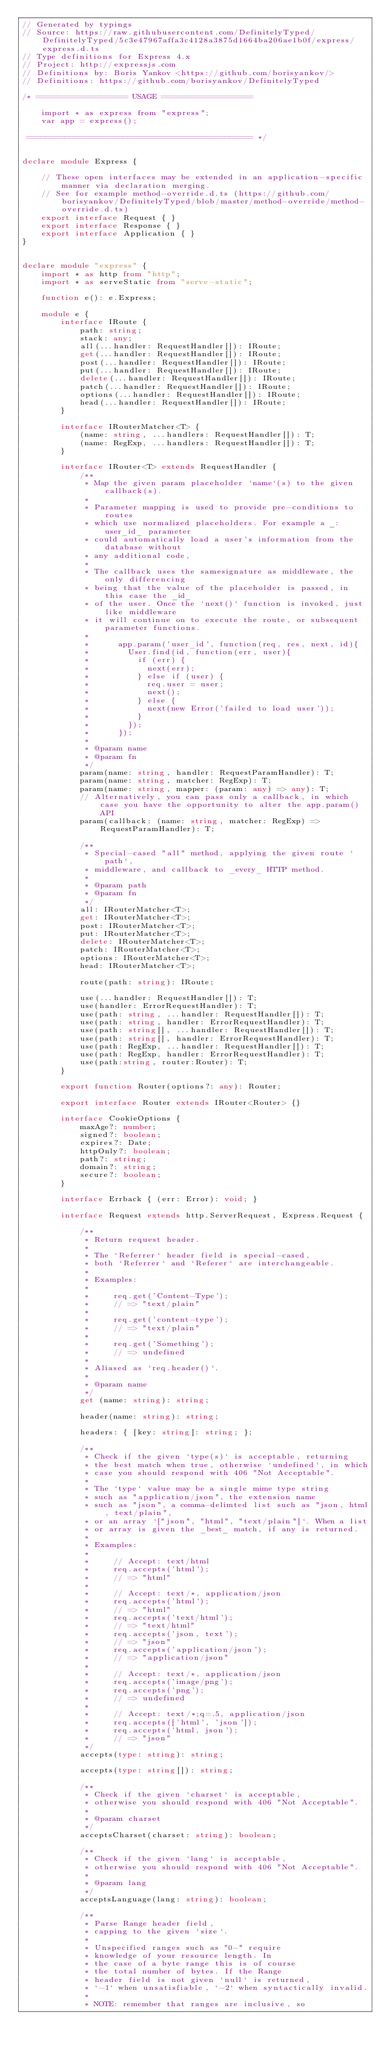Convert code to text. <code><loc_0><loc_0><loc_500><loc_500><_TypeScript_>// Generated by typings
// Source: https://raw.githubusercontent.com/DefinitelyTyped/DefinitelyTyped/5c3e47967affa3c4128a3875d1664ba206ae1b0f/express/express.d.ts
// Type definitions for Express 4.x
// Project: http://expressjs.com
// Definitions by: Boris Yankov <https://github.com/borisyankov/>
// Definitions: https://github.com/borisyankov/DefinitelyTyped

/* =================== USAGE ===================

    import * as express from "express";
    var app = express();

 =============================================== */


declare module Express {

    // These open interfaces may be extended in an application-specific manner via declaration merging.
    // See for example method-override.d.ts (https://github.com/borisyankov/DefinitelyTyped/blob/master/method-override/method-override.d.ts)
    export interface Request { }
    export interface Response { }
    export interface Application { }
}


declare module "express" {
    import * as http from "http";
    import * as serveStatic from "serve-static";

    function e(): e.Express;

    module e {
        interface IRoute {
            path: string;
            stack: any;
            all(...handler: RequestHandler[]): IRoute;
            get(...handler: RequestHandler[]): IRoute;
            post(...handler: RequestHandler[]): IRoute;
            put(...handler: RequestHandler[]): IRoute;
            delete(...handler: RequestHandler[]): IRoute;
            patch(...handler: RequestHandler[]): IRoute;
            options(...handler: RequestHandler[]): IRoute;
            head(...handler: RequestHandler[]): IRoute;
        }

        interface IRouterMatcher<T> {
            (name: string, ...handlers: RequestHandler[]): T;
            (name: RegExp, ...handlers: RequestHandler[]): T;
        }

        interface IRouter<T> extends RequestHandler {
            /**
             * Map the given param placeholder `name`(s) to the given callback(s).
             *
             * Parameter mapping is used to provide pre-conditions to routes
             * which use normalized placeholders. For example a _:user_id_ parameter
             * could automatically load a user's information from the database without
             * any additional code,
             *
             * The callback uses the samesignature as middleware, the only differencing
             * being that the value of the placeholder is passed, in this case the _id_
             * of the user. Once the `next()` function is invoked, just like middleware
             * it will continue on to execute the route, or subsequent parameter functions.
             *
             *      app.param('user_id', function(req, res, next, id){
             *        User.find(id, function(err, user){
             *          if (err) {
             *            next(err);
             *          } else if (user) {
             *            req.user = user;
             *            next();
             *          } else {
             *            next(new Error('failed to load user'));
             *          }
             *        });
             *      });
             *
             * @param name
             * @param fn
             */
            param(name: string, handler: RequestParamHandler): T;
            param(name: string, matcher: RegExp): T;
            param(name: string, mapper: (param: any) => any): T;
            // Alternatively, you can pass only a callback, in which case you have the opportunity to alter the app.param() API
            param(callback: (name: string, matcher: RegExp) => RequestParamHandler): T;

            /**
             * Special-cased "all" method, applying the given route `path`,
             * middleware, and callback to _every_ HTTP method.
             *
             * @param path
             * @param fn
             */
            all: IRouterMatcher<T>;
            get: IRouterMatcher<T>;
            post: IRouterMatcher<T>;
            put: IRouterMatcher<T>;
            delete: IRouterMatcher<T>;
            patch: IRouterMatcher<T>;
            options: IRouterMatcher<T>;
            head: IRouterMatcher<T>;

            route(path: string): IRoute;

            use(...handler: RequestHandler[]): T;
            use(handler: ErrorRequestHandler): T;
            use(path: string, ...handler: RequestHandler[]): T;
            use(path: string, handler: ErrorRequestHandler): T;
            use(path: string[], ...handler: RequestHandler[]): T;
            use(path: string[], handler: ErrorRequestHandler): T;
            use(path: RegExp, ...handler: RequestHandler[]): T;
            use(path: RegExp, handler: ErrorRequestHandler): T;
            use(path:string, router:Router): T;
        }

        export function Router(options?: any): Router;

        export interface Router extends IRouter<Router> {}

        interface CookieOptions {
            maxAge?: number;
            signed?: boolean;
            expires?: Date;
            httpOnly?: boolean;
            path?: string;
            domain?: string;
            secure?: boolean;
        }

        interface Errback { (err: Error): void; }

        interface Request extends http.ServerRequest, Express.Request {

            /**
             * Return request header.
             *
             * The `Referrer` header field is special-cased,
             * both `Referrer` and `Referer` are interchangeable.
             *
             * Examples:
             *
             *     req.get('Content-Type');
             *     // => "text/plain"
             *
             *     req.get('content-type');
             *     // => "text/plain"
             *
             *     req.get('Something');
             *     // => undefined
             *
             * Aliased as `req.header()`.
             *
             * @param name
             */
            get (name: string): string;

            header(name: string): string;

            headers: { [key: string]: string; };

            /**
             * Check if the given `type(s)` is acceptable, returning
             * the best match when true, otherwise `undefined`, in which
             * case you should respond with 406 "Not Acceptable".
             *
             * The `type` value may be a single mime type string
             * such as "application/json", the extension name
             * such as "json", a comma-delimted list such as "json, html, text/plain",
             * or an array `["json", "html", "text/plain"]`. When a list
             * or array is given the _best_ match, if any is returned.
             *
             * Examples:
             *
             *     // Accept: text/html
             *     req.accepts('html');
             *     // => "html"
             *
             *     // Accept: text/*, application/json
             *     req.accepts('html');
             *     // => "html"
             *     req.accepts('text/html');
             *     // => "text/html"
             *     req.accepts('json, text');
             *     // => "json"
             *     req.accepts('application/json');
             *     // => "application/json"
             *
             *     // Accept: text/*, application/json
             *     req.accepts('image/png');
             *     req.accepts('png');
             *     // => undefined
             *
             *     // Accept: text/*;q=.5, application/json
             *     req.accepts(['html', 'json']);
             *     req.accepts('html, json');
             *     // => "json"
             */
            accepts(type: string): string;

            accepts(type: string[]): string;

            /**
             * Check if the given `charset` is acceptable,
             * otherwise you should respond with 406 "Not Acceptable".
             *
             * @param charset
             */
            acceptsCharset(charset: string): boolean;

            /**
             * Check if the given `lang` is acceptable,
             * otherwise you should respond with 406 "Not Acceptable".
             *
             * @param lang
             */
            acceptsLanguage(lang: string): boolean;

            /**
             * Parse Range header field,
             * capping to the given `size`.
             *
             * Unspecified ranges such as "0-" require
             * knowledge of your resource length. In
             * the case of a byte range this is of course
             * the total number of bytes. If the Range
             * header field is not given `null` is returned,
             * `-1` when unsatisfiable, `-2` when syntactically invalid.
             *
             * NOTE: remember that ranges are inclusive, so</code> 